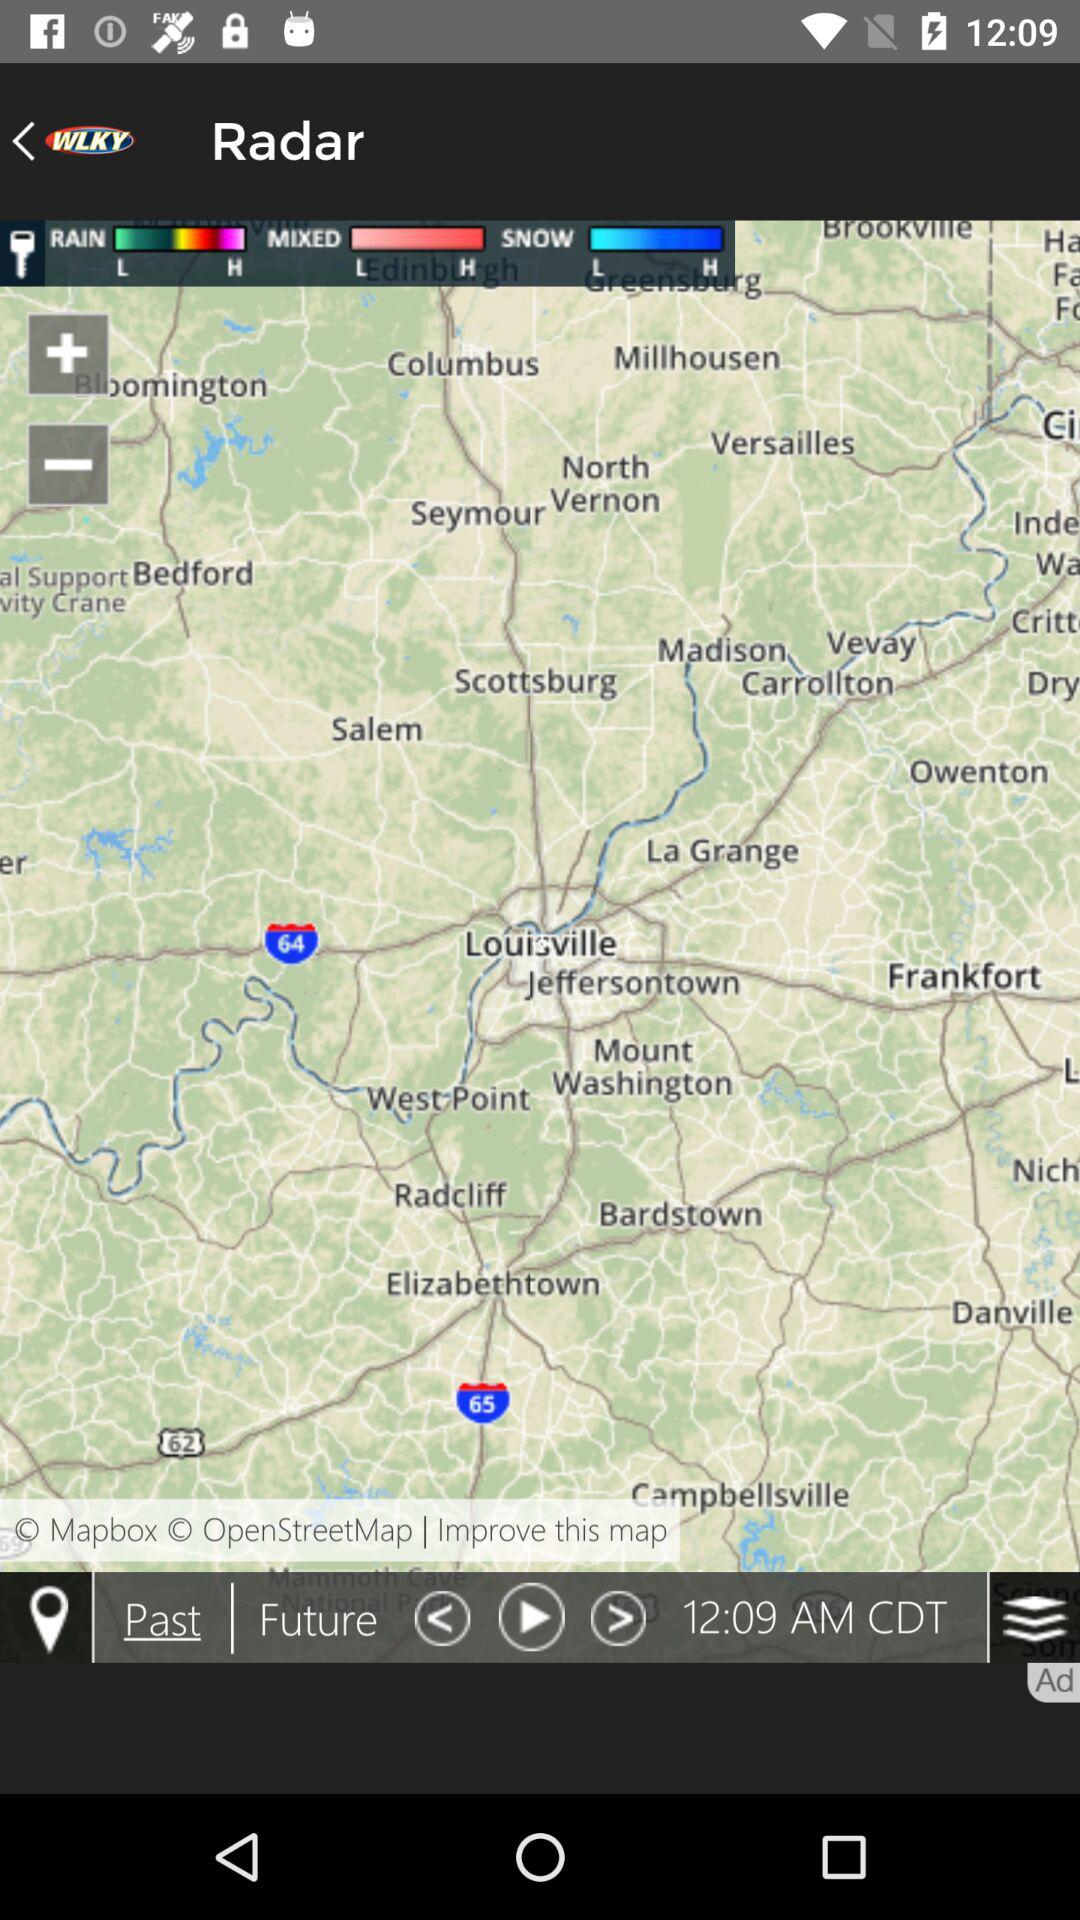What is the given time? The given time is 12:09 AM in Central Daylight Time. 